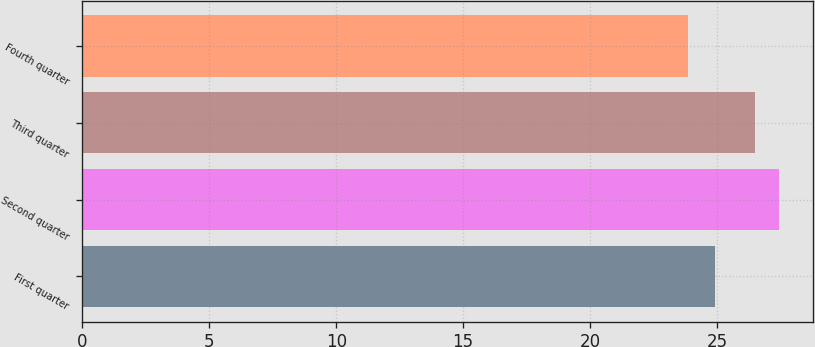<chart> <loc_0><loc_0><loc_500><loc_500><bar_chart><fcel>First quarter<fcel>Second quarter<fcel>Third quarter<fcel>Fourth quarter<nl><fcel>24.9<fcel>27.42<fcel>26.5<fcel>23.87<nl></chart> 